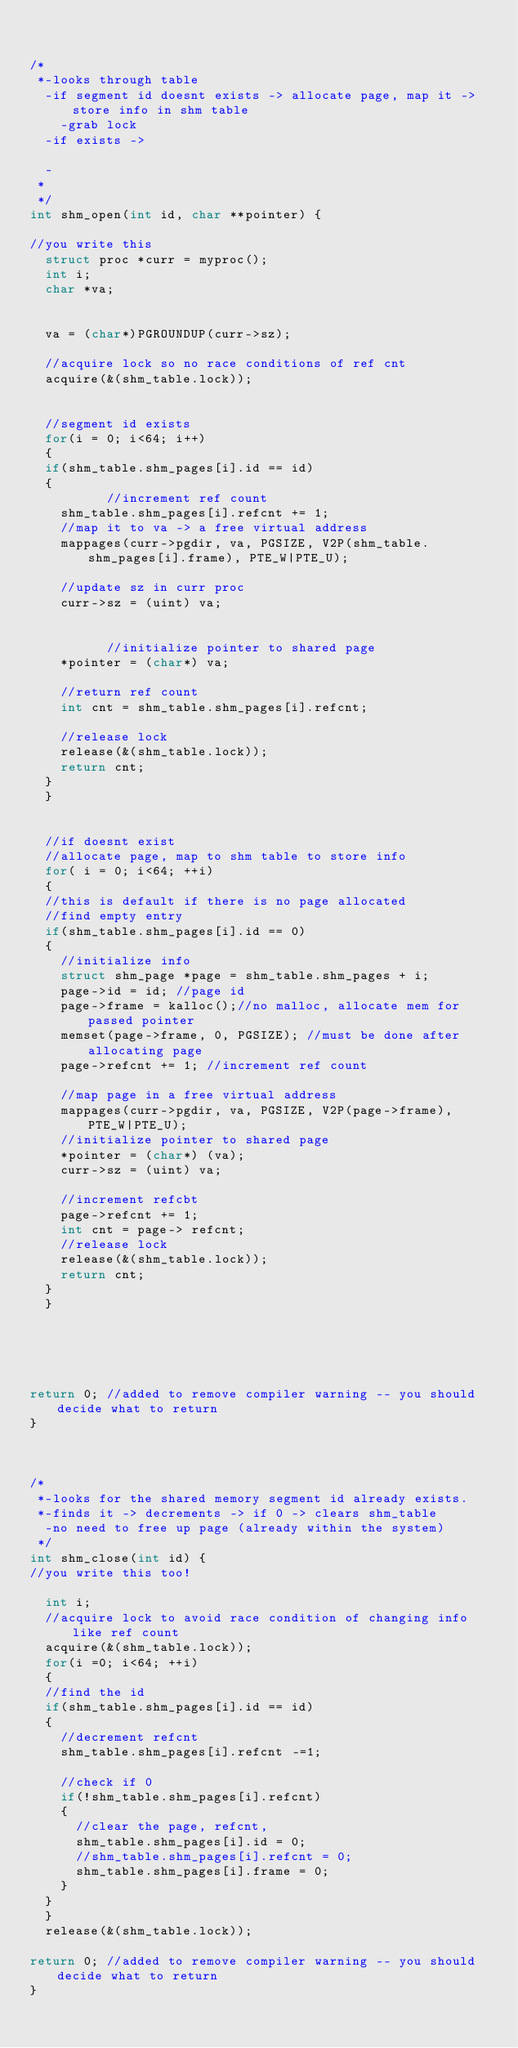Convert code to text. <code><loc_0><loc_0><loc_500><loc_500><_C_>

/*
 *-looks through table
	-if segment id doesnt exists -> allocate page, map it -> store info in shm table
		-grab lock
	-if exists -> 

  -
 *
 */
int shm_open(int id, char **pointer) {

//you write this
  struct proc *curr = myproc();
  int i;
  char *va;
  
  
  va = (char*)PGROUNDUP(curr->sz);
  
  //acquire lock so no race conditions of ref cnt
  acquire(&(shm_table.lock));


  //segment id exists
  for(i = 0; i<64; i++)
  {     
	if(shm_table.shm_pages[i].id == id)
	{ 
          //increment ref count
	  shm_table.shm_pages[i].refcnt += 1;
	  //map it to va -> a free virtual address
	  mappages(curr->pgdir, va, PGSIZE, V2P(shm_table.shm_pages[i].frame), PTE_W|PTE_U);
	  
	  //update sz in curr proc
	  curr->sz = (uint) va;

	  
          //initialize pointer to shared page
	  *pointer = (char*) va;

	  //return ref count
	  int cnt = shm_table.shm_pages[i].refcnt;

	  //release lock
	  release(&(shm_table.lock));
	  return cnt;
	}
  }


  //if doesnt exist
  //allocate page, map to shm table to store info
  for( i = 0; i<64; ++i)
  {
	//this is default if there is no page allocated
	//find empty entry
	if(shm_table.shm_pages[i].id == 0)
	{
		//initialize info
		struct shm_page *page = shm_table.shm_pages + i;
		page->id = id; //page id
		page->frame = kalloc();//no malloc, allocate mem for passed pointer
		memset(page->frame, 0, PGSIZE); //must be done after allocating page
		page->refcnt += 1; //increment ref count

		//map page in a free virtual address
		mappages(curr->pgdir, va, PGSIZE, V2P(page->frame), PTE_W|PTE_U);
		//initialize pointer to shared page
		*pointer = (char*) (va);
		curr->sz = (uint) va;

		//increment refcbt
		page->refcnt += 1;
		int cnt = page-> refcnt;
		//release lock
		release(&(shm_table.lock));
		return cnt;	
	} 
  }
	




return 0; //added to remove compiler warning -- you should decide what to return
}



/*
 *-looks for the shared memory segment id already exists.
 *-finds it -> decrements -> if 0 -> clears shm_table
  -no need to free up page (already within the system)
 */
int shm_close(int id) {
//you write this too!

  int i;
  //acquire lock to avoid race condition of changing info like ref count
  acquire(&(shm_table.lock));
  for(i =0; i<64; ++i)
  {     
	//find the id
	if(shm_table.shm_pages[i].id == id)
	{
		//decrement refcnt
		shm_table.shm_pages[i].refcnt -=1;

		//check if 0
		if(!shm_table.shm_pages[i].refcnt)
		{	
			//clear the page, refcnt, 
			shm_table.shm_pages[i].id = 0;
			//shm_table.shm_pages[i].refcnt = 0;
			shm_table.shm_pages[i].frame = 0;
		}
	}	
  }
  release(&(shm_table.lock));

return 0; //added to remove compiler warning -- you should decide what to return
}
</code> 